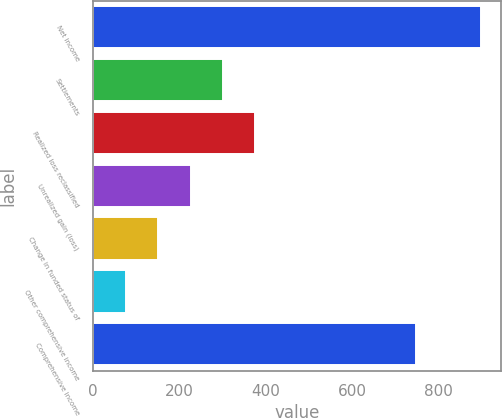Convert chart. <chart><loc_0><loc_0><loc_500><loc_500><bar_chart><fcel>Net income<fcel>Settlements<fcel>Realized loss reclassified<fcel>Unrealized gain (loss)<fcel>Change in funded status of<fcel>Other comprehensive income<fcel>Comprehensive income<nl><fcel>898.28<fcel>300.46<fcel>375.45<fcel>225.47<fcel>150.48<fcel>75.49<fcel>748.3<nl></chart> 